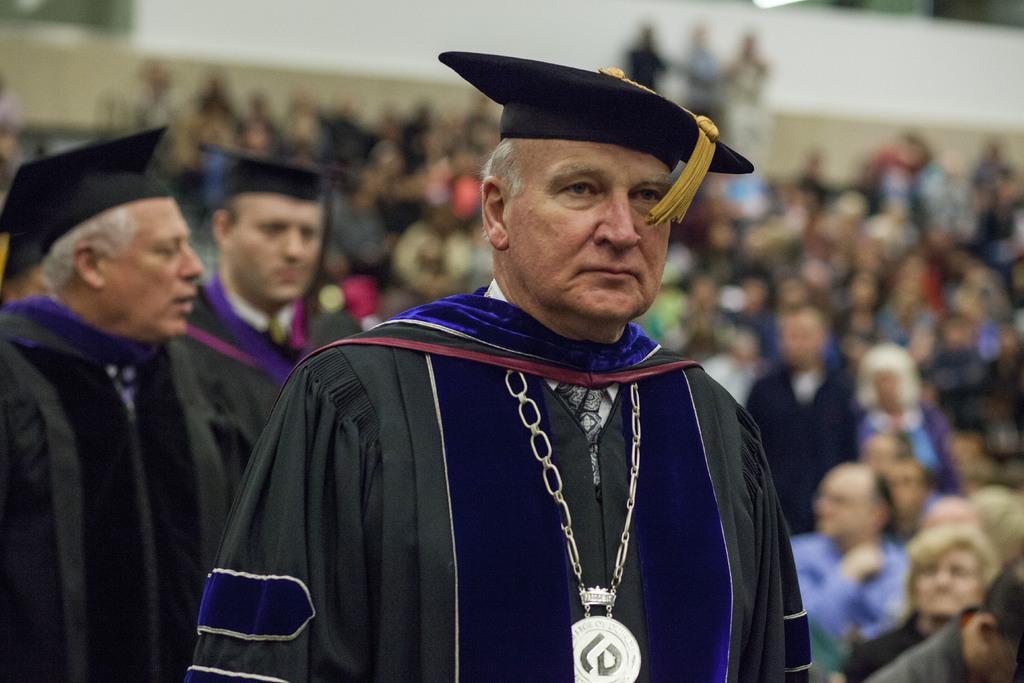Can you describe this image briefly? There are people standing and wore caps. In the background we can see people and it is blurry. 